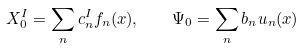<formula> <loc_0><loc_0><loc_500><loc_500>X ^ { I } _ { 0 } = \sum _ { n } c _ { n } ^ { I } f _ { n } ( x ) , \quad \Psi _ { 0 } = \sum _ { n } b _ { n } u _ { n } ( x )</formula> 